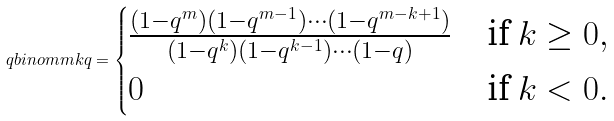<formula> <loc_0><loc_0><loc_500><loc_500>\ q b i n o m m k q = \begin{cases} \frac { ( 1 - q ^ { m } ) ( 1 - q ^ { m - 1 } ) \cdots ( 1 - q ^ { m - k + 1 } ) } { ( 1 - q ^ { k } ) ( 1 - q ^ { k - 1 } ) \cdots ( 1 - q ) } & \text {if $k\geq0$} , \\ 0 & \text {if $k<0$} . \end{cases}</formula> 